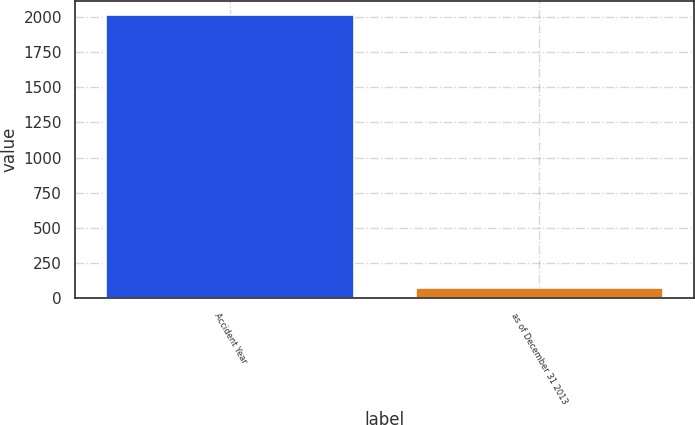Convert chart to OTSL. <chart><loc_0><loc_0><loc_500><loc_500><bar_chart><fcel>Accident Year<fcel>as of December 31 2013<nl><fcel>2013<fcel>75.4<nl></chart> 